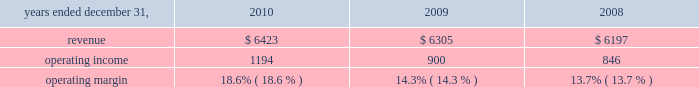Considered to be the primary beneficiary of either entity and have therefore deconsolidated both entities .
At december 31 , 2010 , we held a 36% ( 36 % ) interest in juniperus which is accounted for using the equity method of accounting .
Our potential loss at december 31 , 2010 is limited to our investment of $ 73 million in juniperus , which is recorded in investments in the consolidated statements of financial position .
We have not provided any financing to juniperus other than previously contractually required amounts .
Juniperus and jchl had combined assets and liabilities of $ 121 million and $ 22 million , respectively , at december 31 , 2008 .
For the year ended december 31 , 2009 , we recognized $ 36 million of pretax income from juniperus and jchl .
We recognized $ 16 million of after-tax income , after allocating the appropriate share of net income to the non-controlling interests .
We previously owned an 85% ( 85 % ) economic equity interest in globe re limited ( 2018 2018globe re 2019 2019 ) , a vie , which provided reinsurance coverage for a defined portfolio of property catastrophe reinsurance contracts underwritten by a third party for a limited period which ended june 1 , 2009 .
We consolidated globe re as we were deemed to be the primary beneficiary .
In connection with the winding up of its operations , globe re repaid its $ 100 million of short-term debt and our equity investment from available cash in 2009 .
We recognized $ 2 million of after-tax income from globe re in 2009 , taking into account the share of net income attributable to non-controlling interests .
Globe re was fully liquidated in the third quarter of 2009 .
Review by segment general we serve clients through the following segments : 2022 risk solutions ( formerly risk and insurance brokerage services ) acts as an advisor and insurance and reinsurance broker , helping clients manage their risks , via consultation , as well as negotiation and placement of insurance risk with insurance carriers through our global distribution network .
2022 hr solutions ( formerly consulting ) partners with organizations to solve their most complex benefits , talent and related financial challenges , and improve business performance by designing , implementing , communicating and administering a wide range of human capital , retirement , investment management , health care , compensation and talent management strategies .
Risk solutions .
The demand for property and casualty insurance generally rises as the overall level of economic activity increases and generally falls as such activity decreases , affecting both the commissions and fees generated by our brokerage business .
The economic activity that impacts property and casualty insurance is described as exposure units , and is most closely correlated with employment levels , corporate revenue and asset values .
During 2010 we continued to see a 2018 2018soft market 2019 2019 , which began in 2007 , in our retail brokerage product line .
In a soft market , premium rates flatten or decrease , along with commission revenues , due to increased competition for market share among insurance carriers or increased underwriting capacity .
Changes in premiums have a direct and potentially material impact on the insurance brokerage industry , as commission revenues are generally based on a percentage of the .
What is the growth rate of revenue from 2009 to 2010? 
Computations: ((6423 - 6305) / 6305)
Answer: 0.01872. 